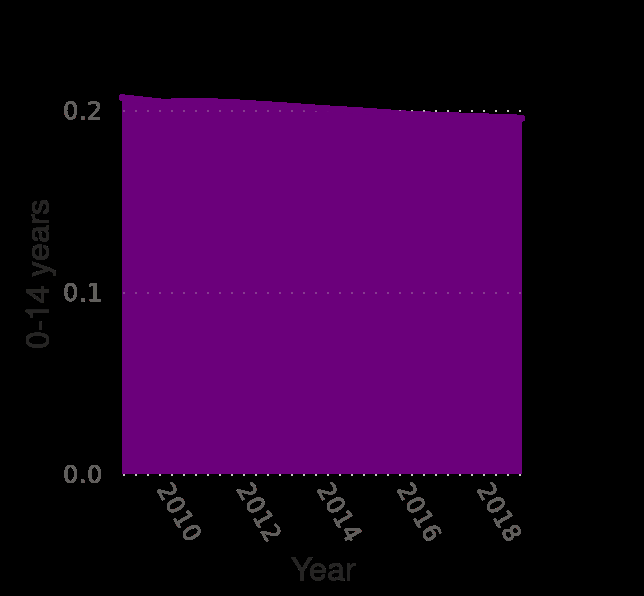<image>
please summary the statistics and relations of the chart There is a steady decline in the age structure of 0-14 year olds from 2010 to 2018. No increase  has been observerd across the period. The ratio dipped below 0.2 around 2015 with no signs of improving. What is the overall trend observed in the age structure of 0-14 year olds from 2010 to 2018? The overall trend is a steady decline in the age structure of 0-14 year olds, with no signs of improvement. 